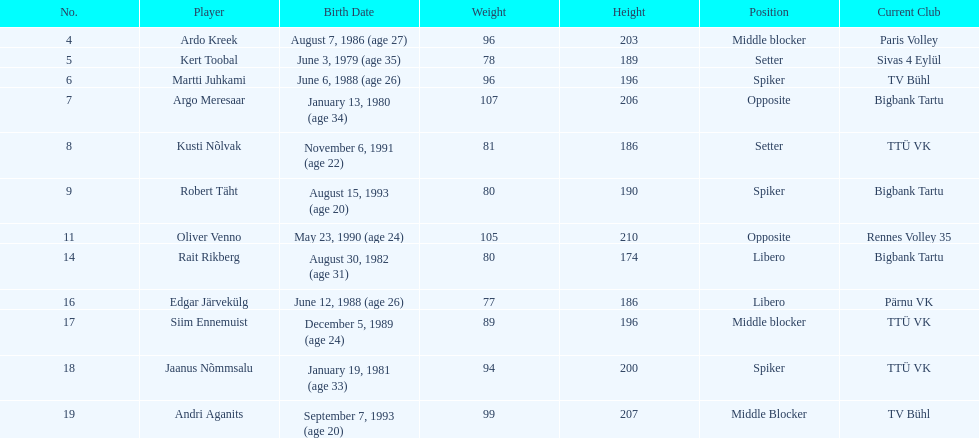How much taller in oliver venno than rait rikberg? 36. 